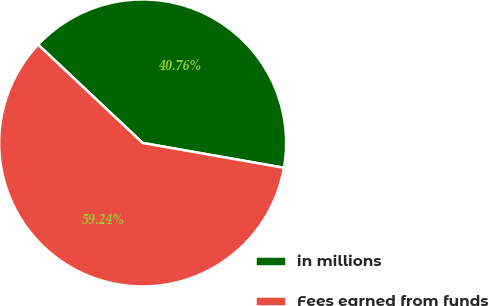<chart> <loc_0><loc_0><loc_500><loc_500><pie_chart><fcel>in millions<fcel>Fees earned from funds<nl><fcel>40.76%<fcel>59.24%<nl></chart> 